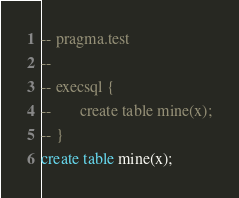<code> <loc_0><loc_0><loc_500><loc_500><_SQL_>-- pragma.test
-- 
-- execsql {
--       create table mine(x);
-- }
create table mine(x);</code> 